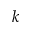Convert formula to latex. <formula><loc_0><loc_0><loc_500><loc_500>k</formula> 